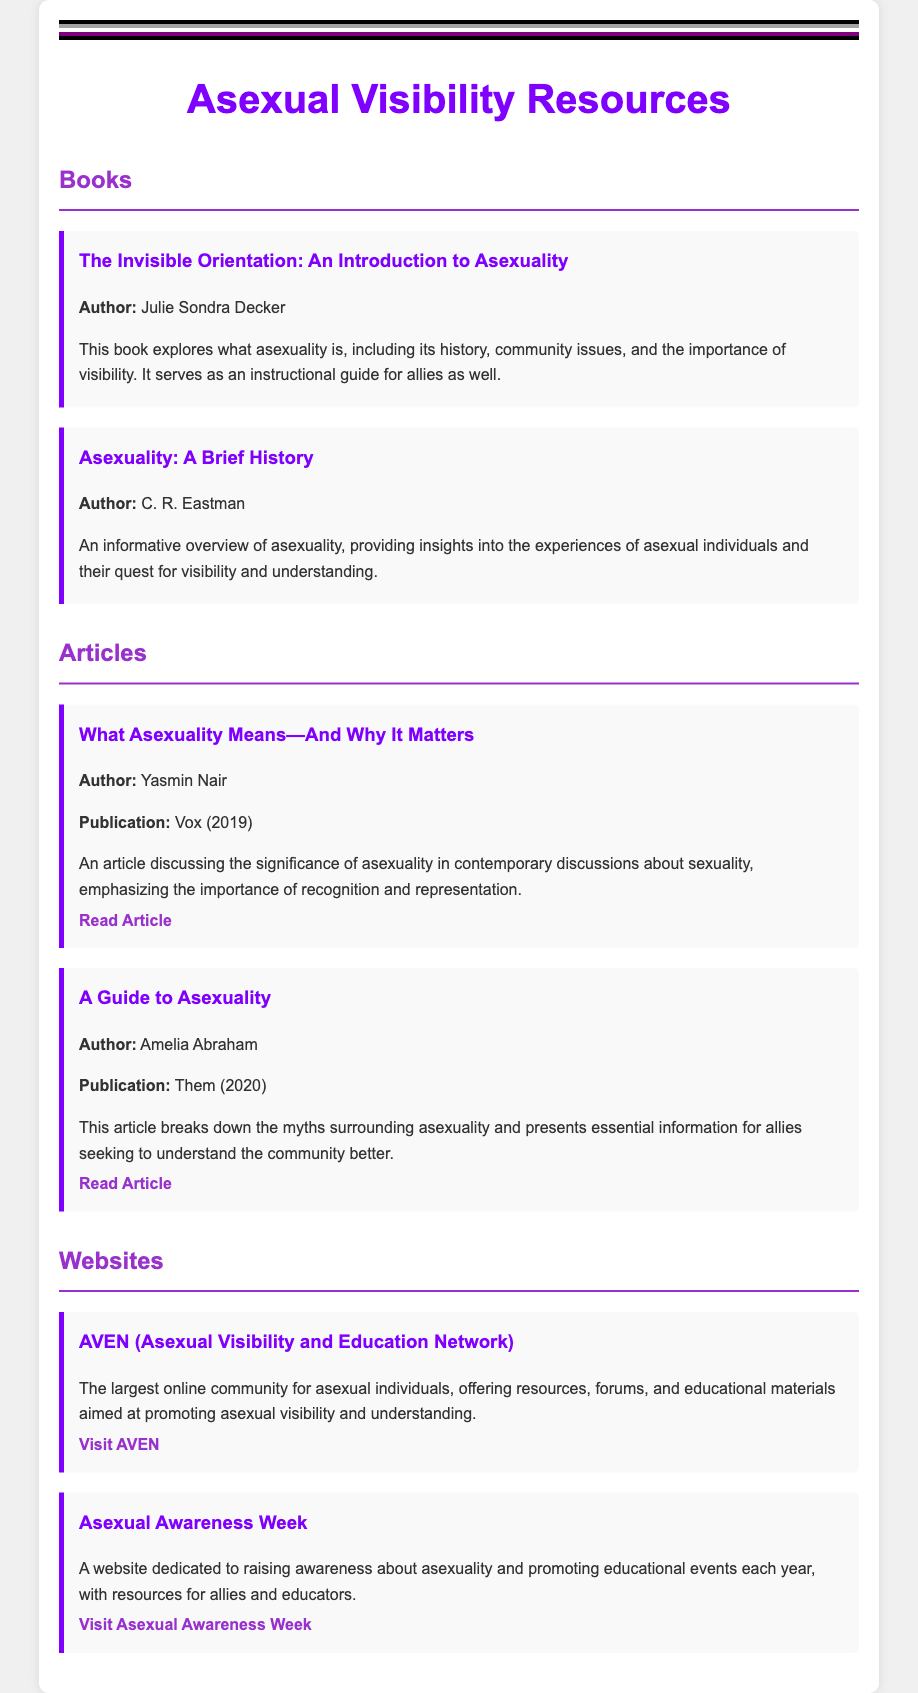What is the title of the resource list? The title of the document is found in the main heading at the top of the content.
Answer: Asexual Visibility Resources Who is the author of "The Invisible Orientation"? The author's name is mentioned directly under the book title in the resource section for books.
Answer: Julie Sondra Decker What year was the article "A Guide to Asexuality" published? The publication year is specified in the article section of the document.
Answer: 2020 What is the main purpose of AVEN? The purpose is outlined in the description of AVEN in the websites section.
Answer: Promoting asexual visibility and understanding Who wrote the article discussing the significance of asexuality? The author is listed beneath the title in the article section of the document.
Answer: Yasmin Nair How many books are listed in the document? The number of books is calculated based on the books section of the resource list.
Answer: 2 What color is used for the main headings in the resource section? The color used for headings can be inferred from the styling attributes shown in the document.
Answer: Purple What is the main theme of the Asexual Awareness Week website? The theme is indicated in the description provided in the websites section.
Answer: Raising awareness about asexuality 